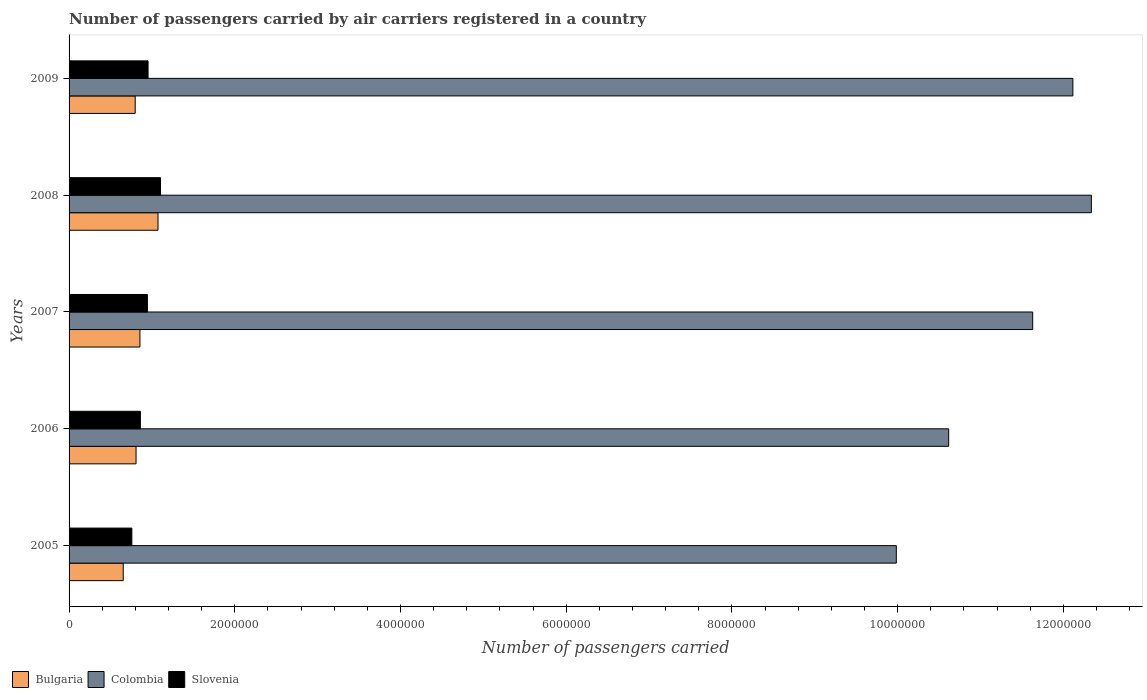How many different coloured bars are there?
Your response must be concise. 3. How many groups of bars are there?
Offer a very short reply. 5. Are the number of bars per tick equal to the number of legend labels?
Your answer should be compact. Yes. How many bars are there on the 3rd tick from the top?
Provide a succinct answer. 3. How many bars are there on the 1st tick from the bottom?
Provide a succinct answer. 3. What is the number of passengers carried by air carriers in Slovenia in 2006?
Offer a terse response. 8.61e+05. Across all years, what is the maximum number of passengers carried by air carriers in Colombia?
Give a very brief answer. 1.23e+07. Across all years, what is the minimum number of passengers carried by air carriers in Colombia?
Ensure brevity in your answer.  9.98e+06. In which year was the number of passengers carried by air carriers in Slovenia minimum?
Your answer should be very brief. 2005. What is the total number of passengers carried by air carriers in Bulgaria in the graph?
Your response must be concise. 4.19e+06. What is the difference between the number of passengers carried by air carriers in Slovenia in 2006 and that in 2008?
Your answer should be compact. -2.43e+05. What is the difference between the number of passengers carried by air carriers in Slovenia in 2006 and the number of passengers carried by air carriers in Colombia in 2007?
Make the answer very short. -1.08e+07. What is the average number of passengers carried by air carriers in Colombia per year?
Ensure brevity in your answer.  1.13e+07. In the year 2008, what is the difference between the number of passengers carried by air carriers in Bulgaria and number of passengers carried by air carriers in Colombia?
Make the answer very short. -1.13e+07. In how many years, is the number of passengers carried by air carriers in Bulgaria greater than 11200000 ?
Provide a succinct answer. 0. What is the ratio of the number of passengers carried by air carriers in Bulgaria in 2007 to that in 2009?
Your answer should be compact. 1.07. Is the number of passengers carried by air carriers in Colombia in 2006 less than that in 2007?
Keep it short and to the point. Yes. What is the difference between the highest and the second highest number of passengers carried by air carriers in Slovenia?
Your answer should be compact. 1.50e+05. What is the difference between the highest and the lowest number of passengers carried by air carriers in Colombia?
Provide a succinct answer. 2.35e+06. In how many years, is the number of passengers carried by air carriers in Bulgaria greater than the average number of passengers carried by air carriers in Bulgaria taken over all years?
Provide a succinct answer. 2. Does the graph contain any zero values?
Make the answer very short. No. How many legend labels are there?
Keep it short and to the point. 3. How are the legend labels stacked?
Your answer should be very brief. Horizontal. What is the title of the graph?
Your response must be concise. Number of passengers carried by air carriers registered in a country. Does "Estonia" appear as one of the legend labels in the graph?
Offer a very short reply. No. What is the label or title of the X-axis?
Your answer should be very brief. Number of passengers carried. What is the Number of passengers carried of Bulgaria in 2005?
Give a very brief answer. 6.54e+05. What is the Number of passengers carried in Colombia in 2005?
Your response must be concise. 9.98e+06. What is the Number of passengers carried in Slovenia in 2005?
Make the answer very short. 7.58e+05. What is the Number of passengers carried in Bulgaria in 2006?
Give a very brief answer. 8.08e+05. What is the Number of passengers carried of Colombia in 2006?
Give a very brief answer. 1.06e+07. What is the Number of passengers carried in Slovenia in 2006?
Offer a very short reply. 8.61e+05. What is the Number of passengers carried in Bulgaria in 2007?
Provide a short and direct response. 8.55e+05. What is the Number of passengers carried of Colombia in 2007?
Ensure brevity in your answer.  1.16e+07. What is the Number of passengers carried of Slovenia in 2007?
Your response must be concise. 9.45e+05. What is the Number of passengers carried in Bulgaria in 2008?
Make the answer very short. 1.07e+06. What is the Number of passengers carried in Colombia in 2008?
Give a very brief answer. 1.23e+07. What is the Number of passengers carried in Slovenia in 2008?
Provide a succinct answer. 1.10e+06. What is the Number of passengers carried of Bulgaria in 2009?
Provide a succinct answer. 7.98e+05. What is the Number of passengers carried in Colombia in 2009?
Make the answer very short. 1.21e+07. What is the Number of passengers carried of Slovenia in 2009?
Make the answer very short. 9.53e+05. Across all years, what is the maximum Number of passengers carried of Bulgaria?
Give a very brief answer. 1.07e+06. Across all years, what is the maximum Number of passengers carried in Colombia?
Offer a terse response. 1.23e+07. Across all years, what is the maximum Number of passengers carried of Slovenia?
Ensure brevity in your answer.  1.10e+06. Across all years, what is the minimum Number of passengers carried in Bulgaria?
Provide a succinct answer. 6.54e+05. Across all years, what is the minimum Number of passengers carried in Colombia?
Provide a succinct answer. 9.98e+06. Across all years, what is the minimum Number of passengers carried in Slovenia?
Provide a short and direct response. 7.58e+05. What is the total Number of passengers carried of Bulgaria in the graph?
Ensure brevity in your answer.  4.19e+06. What is the total Number of passengers carried of Colombia in the graph?
Make the answer very short. 5.67e+07. What is the total Number of passengers carried of Slovenia in the graph?
Ensure brevity in your answer.  4.62e+06. What is the difference between the Number of passengers carried of Bulgaria in 2005 and that in 2006?
Your answer should be very brief. -1.55e+05. What is the difference between the Number of passengers carried of Colombia in 2005 and that in 2006?
Your answer should be compact. -6.32e+05. What is the difference between the Number of passengers carried of Slovenia in 2005 and that in 2006?
Ensure brevity in your answer.  -1.03e+05. What is the difference between the Number of passengers carried in Bulgaria in 2005 and that in 2007?
Offer a terse response. -2.02e+05. What is the difference between the Number of passengers carried in Colombia in 2005 and that in 2007?
Provide a succinct answer. -1.65e+06. What is the difference between the Number of passengers carried in Slovenia in 2005 and that in 2007?
Give a very brief answer. -1.88e+05. What is the difference between the Number of passengers carried of Bulgaria in 2005 and that in 2008?
Ensure brevity in your answer.  -4.20e+05. What is the difference between the Number of passengers carried in Colombia in 2005 and that in 2008?
Provide a succinct answer. -2.35e+06. What is the difference between the Number of passengers carried of Slovenia in 2005 and that in 2008?
Your answer should be very brief. -3.46e+05. What is the difference between the Number of passengers carried in Bulgaria in 2005 and that in 2009?
Your answer should be compact. -1.44e+05. What is the difference between the Number of passengers carried of Colombia in 2005 and that in 2009?
Offer a very short reply. -2.13e+06. What is the difference between the Number of passengers carried in Slovenia in 2005 and that in 2009?
Provide a short and direct response. -1.96e+05. What is the difference between the Number of passengers carried in Bulgaria in 2006 and that in 2007?
Keep it short and to the point. -4.68e+04. What is the difference between the Number of passengers carried in Colombia in 2006 and that in 2007?
Provide a succinct answer. -1.01e+06. What is the difference between the Number of passengers carried in Slovenia in 2006 and that in 2007?
Your response must be concise. -8.47e+04. What is the difference between the Number of passengers carried in Bulgaria in 2006 and that in 2008?
Your answer should be compact. -2.65e+05. What is the difference between the Number of passengers carried in Colombia in 2006 and that in 2008?
Ensure brevity in your answer.  -1.72e+06. What is the difference between the Number of passengers carried in Slovenia in 2006 and that in 2008?
Provide a succinct answer. -2.43e+05. What is the difference between the Number of passengers carried in Bulgaria in 2006 and that in 2009?
Your answer should be very brief. 1.03e+04. What is the difference between the Number of passengers carried in Colombia in 2006 and that in 2009?
Make the answer very short. -1.50e+06. What is the difference between the Number of passengers carried in Slovenia in 2006 and that in 2009?
Provide a succinct answer. -9.26e+04. What is the difference between the Number of passengers carried of Bulgaria in 2007 and that in 2008?
Ensure brevity in your answer.  -2.18e+05. What is the difference between the Number of passengers carried of Colombia in 2007 and that in 2008?
Give a very brief answer. -7.08e+05. What is the difference between the Number of passengers carried of Slovenia in 2007 and that in 2008?
Your answer should be very brief. -1.58e+05. What is the difference between the Number of passengers carried in Bulgaria in 2007 and that in 2009?
Your answer should be compact. 5.71e+04. What is the difference between the Number of passengers carried of Colombia in 2007 and that in 2009?
Offer a very short reply. -4.85e+05. What is the difference between the Number of passengers carried in Slovenia in 2007 and that in 2009?
Offer a terse response. -7958. What is the difference between the Number of passengers carried in Bulgaria in 2008 and that in 2009?
Offer a terse response. 2.75e+05. What is the difference between the Number of passengers carried of Colombia in 2008 and that in 2009?
Provide a succinct answer. 2.23e+05. What is the difference between the Number of passengers carried of Slovenia in 2008 and that in 2009?
Offer a very short reply. 1.50e+05. What is the difference between the Number of passengers carried in Bulgaria in 2005 and the Number of passengers carried in Colombia in 2006?
Your answer should be very brief. -9.96e+06. What is the difference between the Number of passengers carried of Bulgaria in 2005 and the Number of passengers carried of Slovenia in 2006?
Provide a short and direct response. -2.07e+05. What is the difference between the Number of passengers carried of Colombia in 2005 and the Number of passengers carried of Slovenia in 2006?
Offer a very short reply. 9.12e+06. What is the difference between the Number of passengers carried in Bulgaria in 2005 and the Number of passengers carried in Colombia in 2007?
Your response must be concise. -1.10e+07. What is the difference between the Number of passengers carried in Bulgaria in 2005 and the Number of passengers carried in Slovenia in 2007?
Provide a succinct answer. -2.92e+05. What is the difference between the Number of passengers carried of Colombia in 2005 and the Number of passengers carried of Slovenia in 2007?
Keep it short and to the point. 9.04e+06. What is the difference between the Number of passengers carried of Bulgaria in 2005 and the Number of passengers carried of Colombia in 2008?
Ensure brevity in your answer.  -1.17e+07. What is the difference between the Number of passengers carried in Bulgaria in 2005 and the Number of passengers carried in Slovenia in 2008?
Provide a succinct answer. -4.50e+05. What is the difference between the Number of passengers carried of Colombia in 2005 and the Number of passengers carried of Slovenia in 2008?
Provide a short and direct response. 8.88e+06. What is the difference between the Number of passengers carried in Bulgaria in 2005 and the Number of passengers carried in Colombia in 2009?
Provide a succinct answer. -1.15e+07. What is the difference between the Number of passengers carried of Bulgaria in 2005 and the Number of passengers carried of Slovenia in 2009?
Your answer should be very brief. -3.00e+05. What is the difference between the Number of passengers carried in Colombia in 2005 and the Number of passengers carried in Slovenia in 2009?
Offer a very short reply. 9.03e+06. What is the difference between the Number of passengers carried in Bulgaria in 2006 and the Number of passengers carried in Colombia in 2007?
Make the answer very short. -1.08e+07. What is the difference between the Number of passengers carried of Bulgaria in 2006 and the Number of passengers carried of Slovenia in 2007?
Keep it short and to the point. -1.37e+05. What is the difference between the Number of passengers carried in Colombia in 2006 and the Number of passengers carried in Slovenia in 2007?
Your answer should be compact. 9.67e+06. What is the difference between the Number of passengers carried in Bulgaria in 2006 and the Number of passengers carried in Colombia in 2008?
Provide a short and direct response. -1.15e+07. What is the difference between the Number of passengers carried of Bulgaria in 2006 and the Number of passengers carried of Slovenia in 2008?
Provide a succinct answer. -2.95e+05. What is the difference between the Number of passengers carried of Colombia in 2006 and the Number of passengers carried of Slovenia in 2008?
Give a very brief answer. 9.51e+06. What is the difference between the Number of passengers carried in Bulgaria in 2006 and the Number of passengers carried in Colombia in 2009?
Provide a succinct answer. -1.13e+07. What is the difference between the Number of passengers carried of Bulgaria in 2006 and the Number of passengers carried of Slovenia in 2009?
Your response must be concise. -1.45e+05. What is the difference between the Number of passengers carried in Colombia in 2006 and the Number of passengers carried in Slovenia in 2009?
Make the answer very short. 9.66e+06. What is the difference between the Number of passengers carried of Bulgaria in 2007 and the Number of passengers carried of Colombia in 2008?
Your response must be concise. -1.15e+07. What is the difference between the Number of passengers carried of Bulgaria in 2007 and the Number of passengers carried of Slovenia in 2008?
Provide a succinct answer. -2.48e+05. What is the difference between the Number of passengers carried in Colombia in 2007 and the Number of passengers carried in Slovenia in 2008?
Keep it short and to the point. 1.05e+07. What is the difference between the Number of passengers carried of Bulgaria in 2007 and the Number of passengers carried of Colombia in 2009?
Offer a terse response. -1.13e+07. What is the difference between the Number of passengers carried in Bulgaria in 2007 and the Number of passengers carried in Slovenia in 2009?
Your response must be concise. -9.81e+04. What is the difference between the Number of passengers carried in Colombia in 2007 and the Number of passengers carried in Slovenia in 2009?
Provide a succinct answer. 1.07e+07. What is the difference between the Number of passengers carried of Bulgaria in 2008 and the Number of passengers carried of Colombia in 2009?
Give a very brief answer. -1.10e+07. What is the difference between the Number of passengers carried in Bulgaria in 2008 and the Number of passengers carried in Slovenia in 2009?
Offer a very short reply. 1.20e+05. What is the difference between the Number of passengers carried in Colombia in 2008 and the Number of passengers carried in Slovenia in 2009?
Provide a succinct answer. 1.14e+07. What is the average Number of passengers carried in Bulgaria per year?
Your answer should be compact. 8.38e+05. What is the average Number of passengers carried in Colombia per year?
Your response must be concise. 1.13e+07. What is the average Number of passengers carried of Slovenia per year?
Provide a succinct answer. 9.24e+05. In the year 2005, what is the difference between the Number of passengers carried of Bulgaria and Number of passengers carried of Colombia?
Give a very brief answer. -9.33e+06. In the year 2005, what is the difference between the Number of passengers carried of Bulgaria and Number of passengers carried of Slovenia?
Your answer should be very brief. -1.04e+05. In the year 2005, what is the difference between the Number of passengers carried in Colombia and Number of passengers carried in Slovenia?
Offer a very short reply. 9.23e+06. In the year 2006, what is the difference between the Number of passengers carried in Bulgaria and Number of passengers carried in Colombia?
Keep it short and to the point. -9.81e+06. In the year 2006, what is the difference between the Number of passengers carried in Bulgaria and Number of passengers carried in Slovenia?
Offer a very short reply. -5.23e+04. In the year 2006, what is the difference between the Number of passengers carried in Colombia and Number of passengers carried in Slovenia?
Your response must be concise. 9.76e+06. In the year 2007, what is the difference between the Number of passengers carried of Bulgaria and Number of passengers carried of Colombia?
Provide a short and direct response. -1.08e+07. In the year 2007, what is the difference between the Number of passengers carried in Bulgaria and Number of passengers carried in Slovenia?
Your response must be concise. -9.02e+04. In the year 2007, what is the difference between the Number of passengers carried in Colombia and Number of passengers carried in Slovenia?
Offer a terse response. 1.07e+07. In the year 2008, what is the difference between the Number of passengers carried of Bulgaria and Number of passengers carried of Colombia?
Make the answer very short. -1.13e+07. In the year 2008, what is the difference between the Number of passengers carried in Bulgaria and Number of passengers carried in Slovenia?
Offer a very short reply. -3.02e+04. In the year 2008, what is the difference between the Number of passengers carried of Colombia and Number of passengers carried of Slovenia?
Your answer should be compact. 1.12e+07. In the year 2009, what is the difference between the Number of passengers carried of Bulgaria and Number of passengers carried of Colombia?
Your response must be concise. -1.13e+07. In the year 2009, what is the difference between the Number of passengers carried of Bulgaria and Number of passengers carried of Slovenia?
Keep it short and to the point. -1.55e+05. In the year 2009, what is the difference between the Number of passengers carried of Colombia and Number of passengers carried of Slovenia?
Give a very brief answer. 1.12e+07. What is the ratio of the Number of passengers carried in Bulgaria in 2005 to that in 2006?
Keep it short and to the point. 0.81. What is the ratio of the Number of passengers carried in Colombia in 2005 to that in 2006?
Provide a short and direct response. 0.94. What is the ratio of the Number of passengers carried in Slovenia in 2005 to that in 2006?
Your answer should be very brief. 0.88. What is the ratio of the Number of passengers carried of Bulgaria in 2005 to that in 2007?
Provide a succinct answer. 0.76. What is the ratio of the Number of passengers carried in Colombia in 2005 to that in 2007?
Ensure brevity in your answer.  0.86. What is the ratio of the Number of passengers carried in Slovenia in 2005 to that in 2007?
Ensure brevity in your answer.  0.8. What is the ratio of the Number of passengers carried of Bulgaria in 2005 to that in 2008?
Your answer should be compact. 0.61. What is the ratio of the Number of passengers carried of Colombia in 2005 to that in 2008?
Provide a short and direct response. 0.81. What is the ratio of the Number of passengers carried in Slovenia in 2005 to that in 2008?
Provide a short and direct response. 0.69. What is the ratio of the Number of passengers carried of Bulgaria in 2005 to that in 2009?
Provide a succinct answer. 0.82. What is the ratio of the Number of passengers carried of Colombia in 2005 to that in 2009?
Offer a very short reply. 0.82. What is the ratio of the Number of passengers carried of Slovenia in 2005 to that in 2009?
Your answer should be compact. 0.79. What is the ratio of the Number of passengers carried in Bulgaria in 2006 to that in 2007?
Offer a very short reply. 0.95. What is the ratio of the Number of passengers carried in Colombia in 2006 to that in 2007?
Provide a succinct answer. 0.91. What is the ratio of the Number of passengers carried in Slovenia in 2006 to that in 2007?
Give a very brief answer. 0.91. What is the ratio of the Number of passengers carried in Bulgaria in 2006 to that in 2008?
Your answer should be compact. 0.75. What is the ratio of the Number of passengers carried of Colombia in 2006 to that in 2008?
Your response must be concise. 0.86. What is the ratio of the Number of passengers carried in Slovenia in 2006 to that in 2008?
Keep it short and to the point. 0.78. What is the ratio of the Number of passengers carried of Bulgaria in 2006 to that in 2009?
Provide a short and direct response. 1.01. What is the ratio of the Number of passengers carried in Colombia in 2006 to that in 2009?
Provide a succinct answer. 0.88. What is the ratio of the Number of passengers carried in Slovenia in 2006 to that in 2009?
Keep it short and to the point. 0.9. What is the ratio of the Number of passengers carried in Bulgaria in 2007 to that in 2008?
Make the answer very short. 0.8. What is the ratio of the Number of passengers carried of Colombia in 2007 to that in 2008?
Provide a succinct answer. 0.94. What is the ratio of the Number of passengers carried of Slovenia in 2007 to that in 2008?
Keep it short and to the point. 0.86. What is the ratio of the Number of passengers carried of Bulgaria in 2007 to that in 2009?
Your answer should be very brief. 1.07. What is the ratio of the Number of passengers carried in Slovenia in 2007 to that in 2009?
Give a very brief answer. 0.99. What is the ratio of the Number of passengers carried of Bulgaria in 2008 to that in 2009?
Keep it short and to the point. 1.34. What is the ratio of the Number of passengers carried of Colombia in 2008 to that in 2009?
Your response must be concise. 1.02. What is the ratio of the Number of passengers carried in Slovenia in 2008 to that in 2009?
Keep it short and to the point. 1.16. What is the difference between the highest and the second highest Number of passengers carried in Bulgaria?
Provide a succinct answer. 2.18e+05. What is the difference between the highest and the second highest Number of passengers carried in Colombia?
Keep it short and to the point. 2.23e+05. What is the difference between the highest and the second highest Number of passengers carried in Slovenia?
Your answer should be very brief. 1.50e+05. What is the difference between the highest and the lowest Number of passengers carried of Bulgaria?
Ensure brevity in your answer.  4.20e+05. What is the difference between the highest and the lowest Number of passengers carried of Colombia?
Keep it short and to the point. 2.35e+06. What is the difference between the highest and the lowest Number of passengers carried of Slovenia?
Keep it short and to the point. 3.46e+05. 